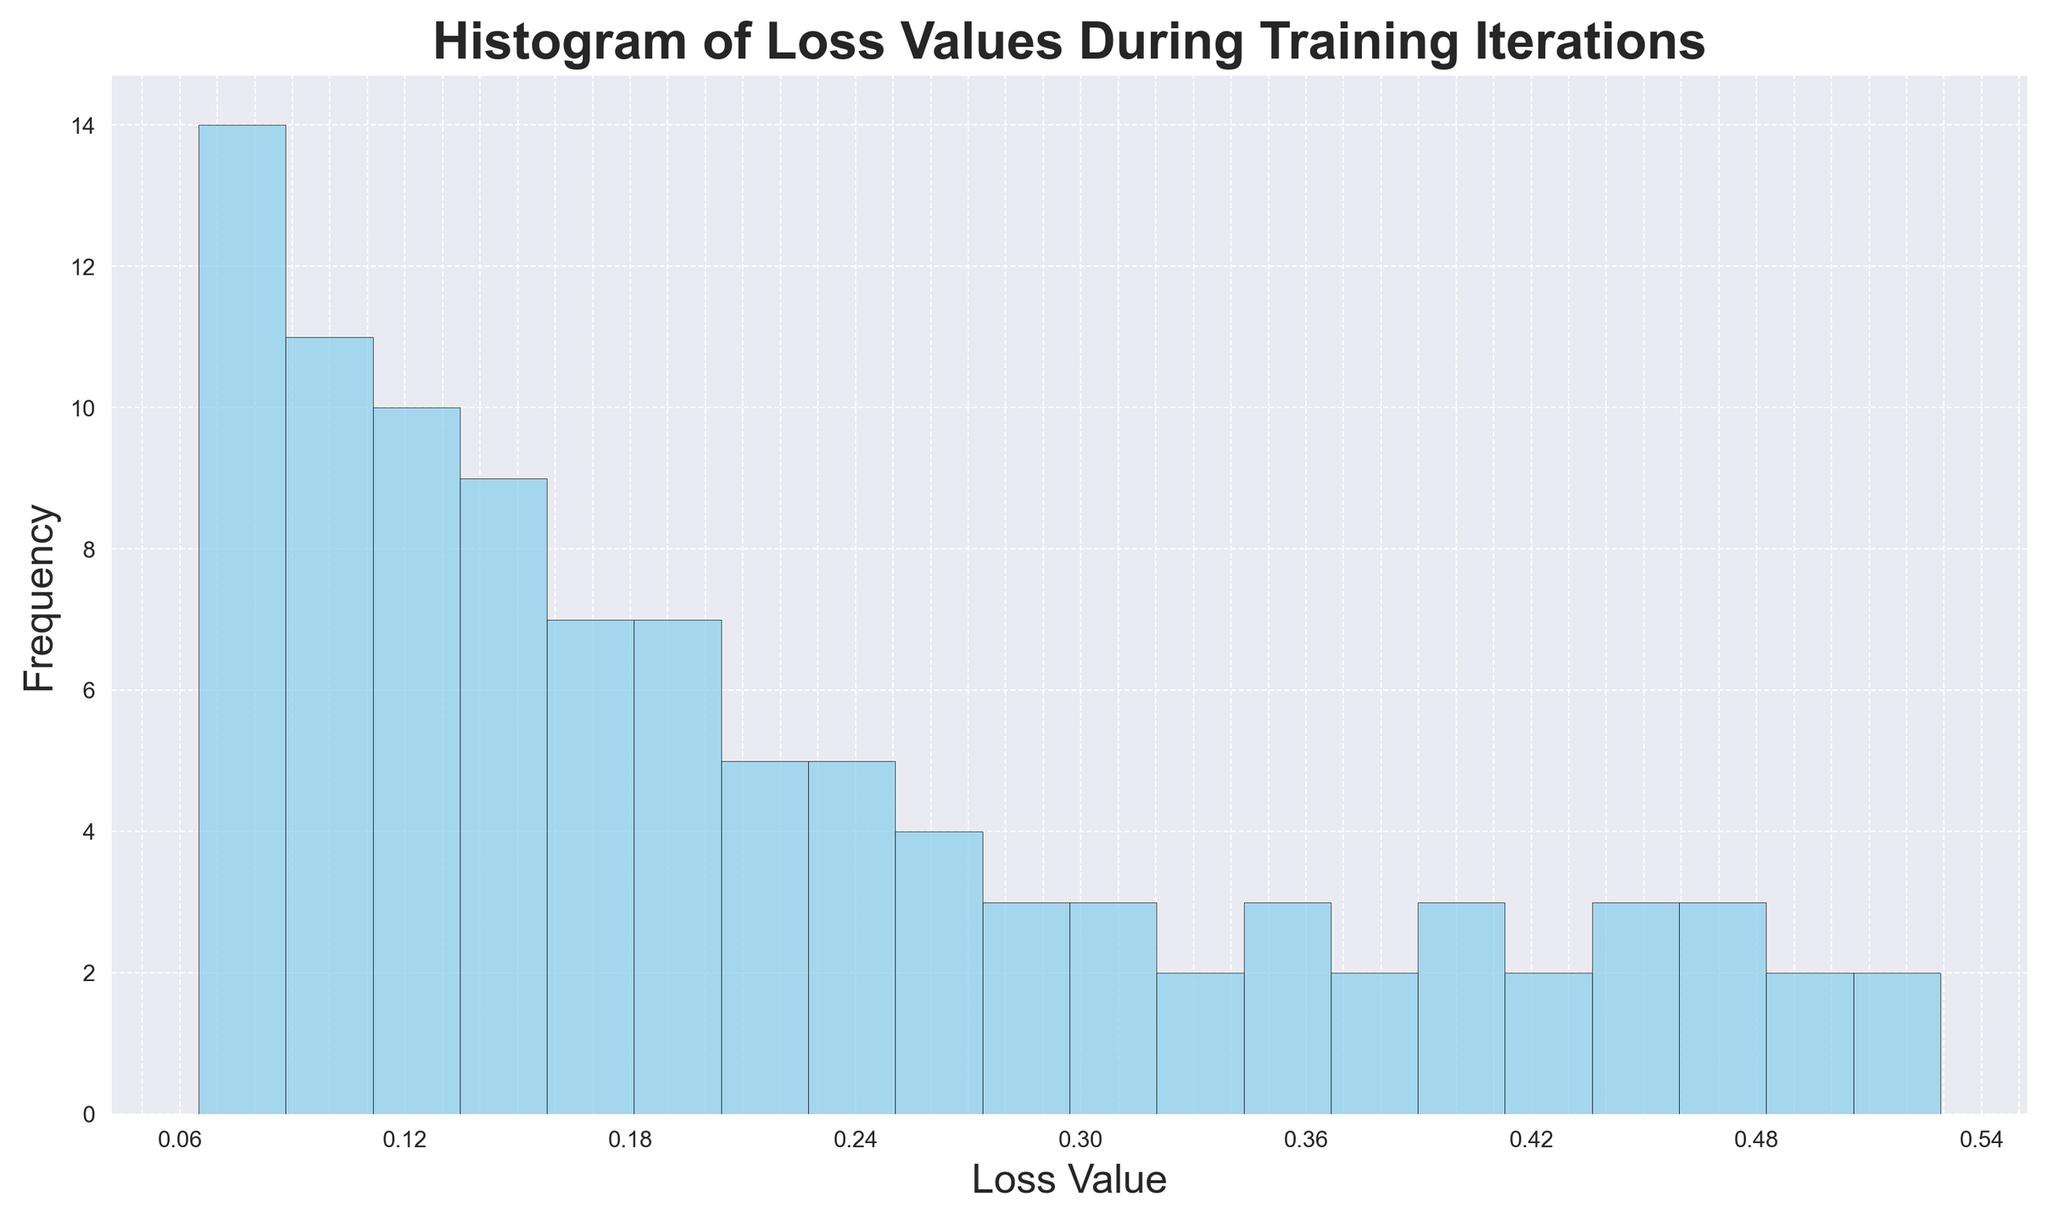What is the most frequent range of loss values? To find the most frequent range of loss values, observe the histogram and identify the bar (or bins) which has the highest frequency value (the tallest bar).
Answer: 0.02-0.08 What is the least frequent range of loss values? Check the histogram and note which bar has the lowest frequency value. Ensure you are focusing on bars that show any height, indicating they have at least some frequency of occurrence.
Answer: 0.48-0.53 What is the sum of the frequencies in the 0.11-0.13 and 0.36-0.38 ranges? Find and sum the heights (frequencies) of the bars corresponding to the 0.11-0.13 range and the 0.36-0.38 range.
Answer: 11 How do the frequencies in the 0.2-0.25 range compare to those in the 0.05-0.10 range? Compare the heights of the bars in these two ranges. The 0.05-0.10 range has taller bars compared to the 0.2-0.25 range, indicating higher frequencies.
Answer: Higher in 0.05-0.10 What range has the second-highest frequency? After identifying the highest frequency range, find the next tallest bar to determine the range with the second-highest frequency.
Answer: 0.08-0.13 What can you say about the overall trend in loss values? Observe the shape and skew of the histogram. The loss values appear to decrease over time, as indicated by more frequent lower values on the right side.
Answer: Decreasing trend Which range has more loss values, 0.3-0.33 or 0.4-0.43? Compare the sum of frequencies in the 0.3-0.33 range and the 0.4-0.43 range by looking at the heights of the bars within these ranges.
Answer: 0.3-0.33 What proportion of loss values falls below 0.2? Count the bars in the histogram that represent loss values below 0.2 and sum their frequencies. Divide this sum by the total number of data points (100).
Answer: 52% How many bins have a frequency greater than or equal to 10? Count the number of bars in the histogram whose heights (frequencies) are 10 or greater.
Answer: 5 